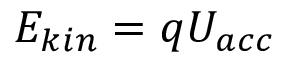Convert formula to latex. <formula><loc_0><loc_0><loc_500><loc_500>E _ { k i n } = q U _ { a c c }</formula> 